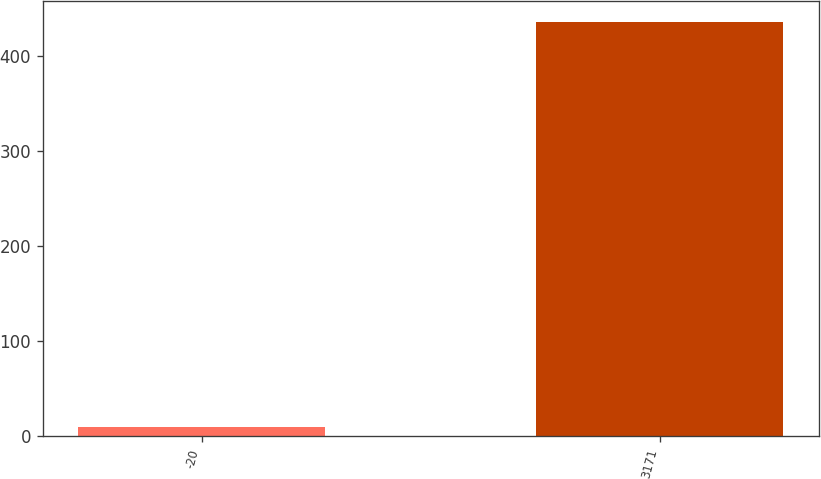Convert chart. <chart><loc_0><loc_0><loc_500><loc_500><bar_chart><fcel>-20<fcel>3171<nl><fcel>10<fcel>436<nl></chart> 